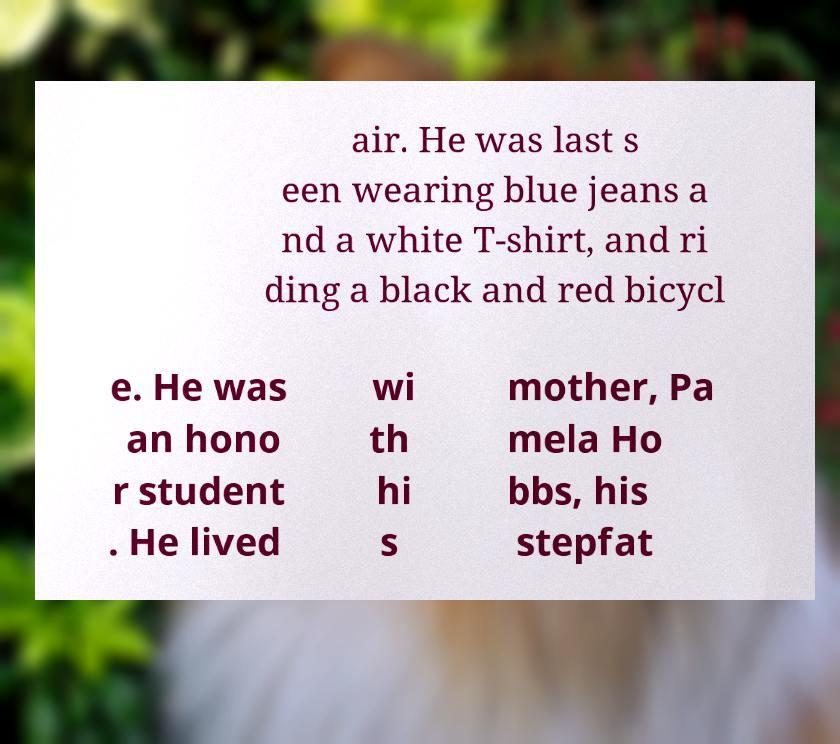Can you accurately transcribe the text from the provided image for me? air. He was last s een wearing blue jeans a nd a white T-shirt, and ri ding a black and red bicycl e. He was an hono r student . He lived wi th hi s mother, Pa mela Ho bbs, his stepfat 